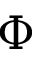<formula> <loc_0><loc_0><loc_500><loc_500>\Phi</formula> 